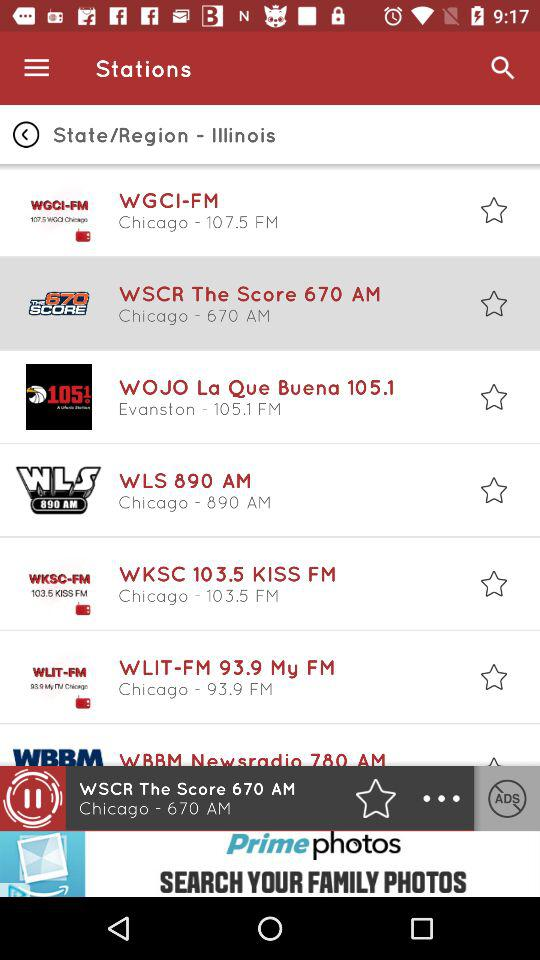Which station is currently playing? The station is "WSCR The Score 670 AM". 